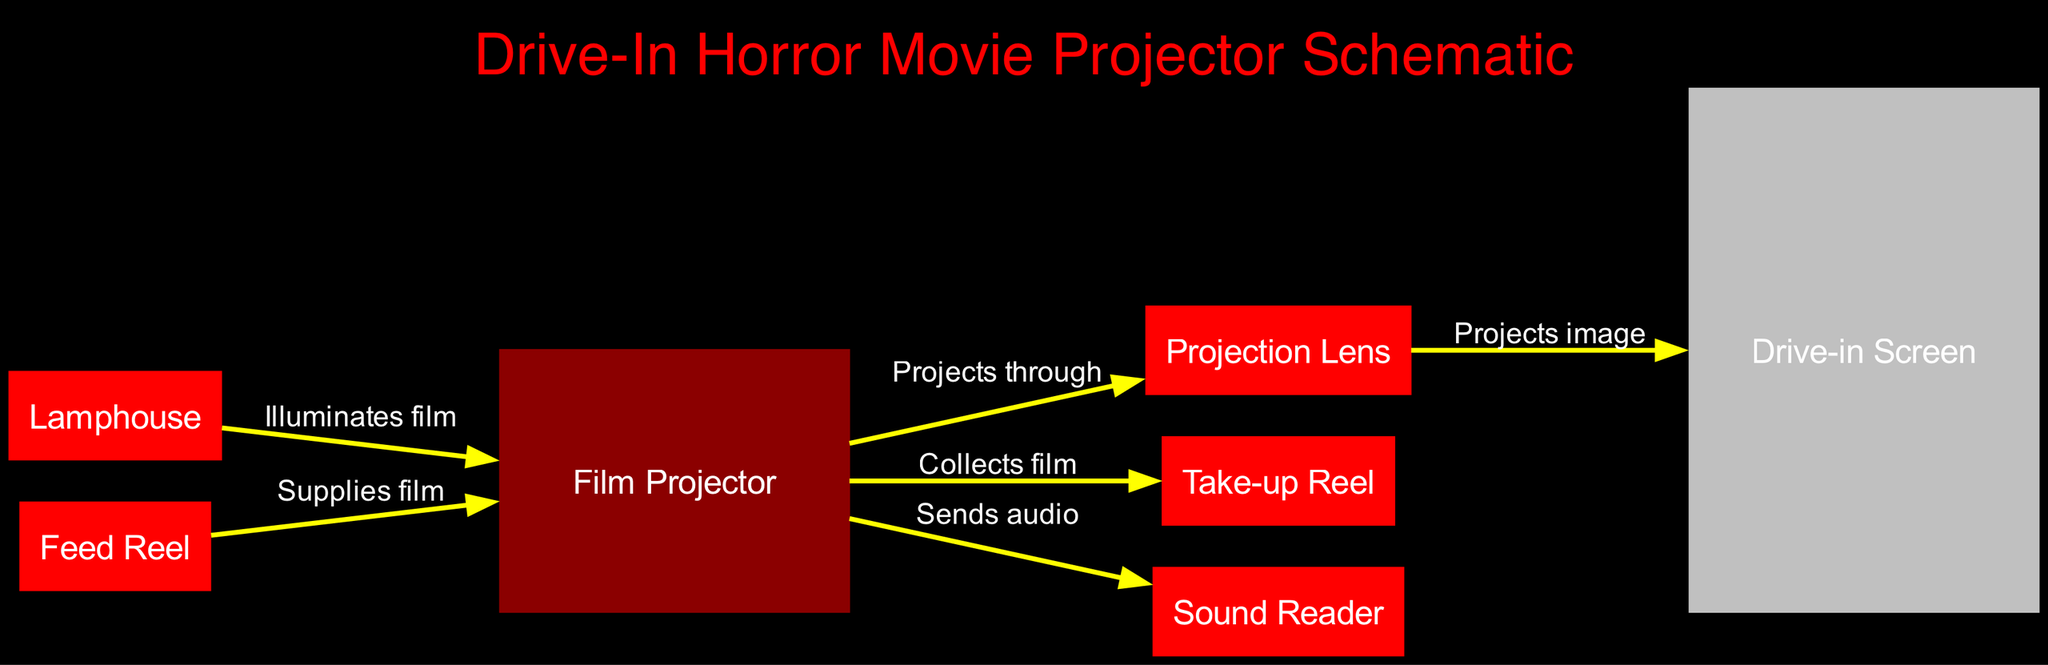What's the total number of nodes in the diagram? The diagram includes several nodes: Film Projector, Projection Lens, Lamphouse, Feed Reel, Take-up Reel, Sound Reader, and Drive-in Screen. Counting these gives a total of seven nodes.
Answer: 7 What does the Lamphouse do according to the diagram? The Lamphouse is connected to the projector and is labeled as illuminating the film. This means its function is to provide the necessary light for projecting the film.
Answer: Illuminates film Which node does the Projection Lens project the image onto? According to the diagram, the Projection Lens projects the image onto the Drive-in Screen. The label on the edge connecting these two nodes indicates this relationship.
Answer: Drive-in Screen What is the function of the Feed Reel in the diagram? The Feed Reel supplies film to the projector, as indicated by the label on the edge connecting these two nodes. This means the Feed Reel holds the film that gets fed into the projector for projection.
Answer: Supplies film Which component collects the film after projection? The diagram shows that the Take-up Reel is the component that collects the film after it has been projected, as stated by the label on the edge leading from the projector to the Take-up Reel.
Answer: Collects film What are the two components directly involved in audio transmission? The two components involved in audio transmission are the projector and the sound reader. The edge between them indicates that the projector sends audio to the sound reader.
Answer: Projector, Sound Reader Describe the flow of the film in the diagram from the Feed Reel to the Take-up Reel. The flow starts at the Feed Reel, which supplies film to the projector. The projector then collects the film and passes it to the Take-up Reel. This outlines a clear sequence of operations where the film moves from the source to the collection point.
Answer: Feed Reel to Projector to Take-up Reel How is the Drive-in Screen represented in the diagram? The Drive-in Screen is represented as a rectangle node with a gray color, emphasizing its role in the projection system. This visual distinction highlights that it's different from the other components in terms of function.
Answer: Gray rectangle What type of diagram is shown here? The diagram represents an engineering schematic specifically focused on the configuration and relationships within a film projector used for horror movie screenings. The use of nodes and edges indicates this is an engineering diagram.
Answer: Engineering Schematic 